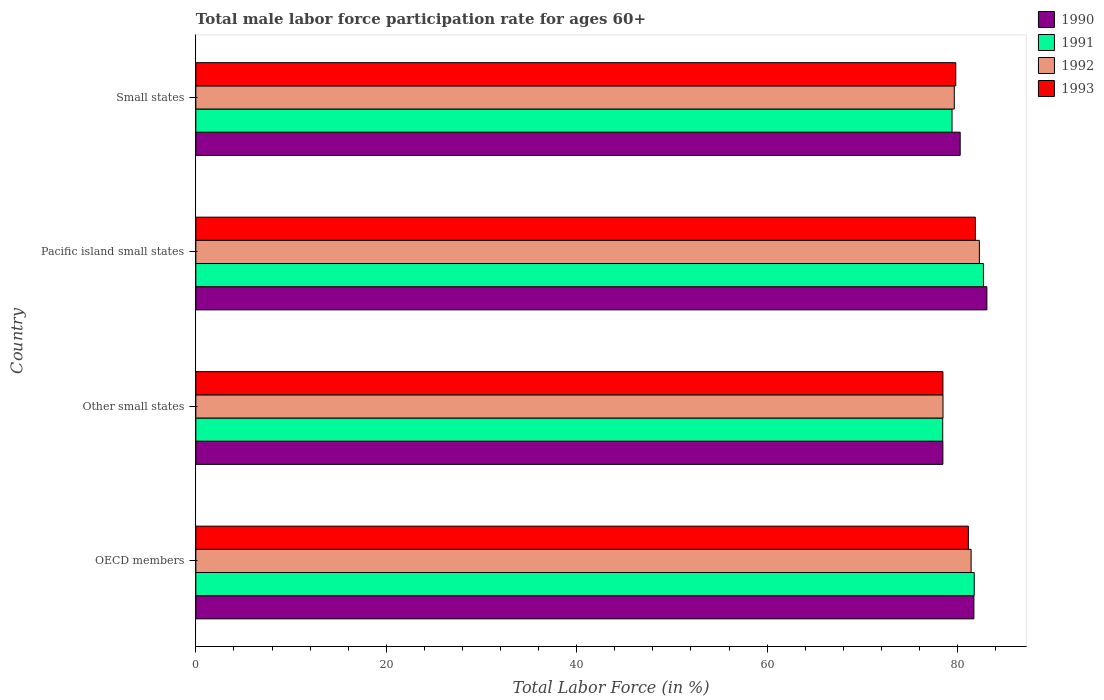How many different coloured bars are there?
Make the answer very short. 4. Are the number of bars per tick equal to the number of legend labels?
Offer a very short reply. Yes. How many bars are there on the 1st tick from the bottom?
Your answer should be very brief. 4. What is the label of the 2nd group of bars from the top?
Your answer should be compact. Pacific island small states. In how many cases, is the number of bars for a given country not equal to the number of legend labels?
Provide a succinct answer. 0. What is the male labor force participation rate in 1991 in Pacific island small states?
Your answer should be very brief. 82.72. Across all countries, what is the maximum male labor force participation rate in 1993?
Your answer should be very brief. 81.87. Across all countries, what is the minimum male labor force participation rate in 1990?
Ensure brevity in your answer.  78.46. In which country was the male labor force participation rate in 1991 maximum?
Your answer should be very brief. Pacific island small states. In which country was the male labor force participation rate in 1992 minimum?
Your answer should be very brief. Other small states. What is the total male labor force participation rate in 1992 in the graph?
Provide a short and direct response. 321.87. What is the difference between the male labor force participation rate in 1990 in OECD members and that in Other small states?
Give a very brief answer. 3.26. What is the difference between the male labor force participation rate in 1990 in OECD members and the male labor force participation rate in 1993 in Small states?
Keep it short and to the point. 1.9. What is the average male labor force participation rate in 1992 per country?
Your answer should be very brief. 80.47. What is the difference between the male labor force participation rate in 1993 and male labor force participation rate in 1990 in Pacific island small states?
Make the answer very short. -1.21. In how many countries, is the male labor force participation rate in 1992 greater than 36 %?
Your response must be concise. 4. What is the ratio of the male labor force participation rate in 1990 in OECD members to that in Pacific island small states?
Your answer should be compact. 0.98. Is the male labor force participation rate in 1990 in OECD members less than that in Pacific island small states?
Provide a short and direct response. Yes. What is the difference between the highest and the second highest male labor force participation rate in 1991?
Provide a succinct answer. 0.97. What is the difference between the highest and the lowest male labor force participation rate in 1990?
Ensure brevity in your answer.  4.62. In how many countries, is the male labor force participation rate in 1992 greater than the average male labor force participation rate in 1992 taken over all countries?
Your response must be concise. 2. Is the sum of the male labor force participation rate in 1993 in OECD members and Other small states greater than the maximum male labor force participation rate in 1992 across all countries?
Offer a terse response. Yes. What does the 3rd bar from the top in Other small states represents?
Offer a very short reply. 1991. How many bars are there?
Offer a terse response. 16. Are all the bars in the graph horizontal?
Your answer should be very brief. Yes. How many countries are there in the graph?
Make the answer very short. 4. What is the difference between two consecutive major ticks on the X-axis?
Your response must be concise. 20. Are the values on the major ticks of X-axis written in scientific E-notation?
Your response must be concise. No. Does the graph contain grids?
Give a very brief answer. No. Where does the legend appear in the graph?
Make the answer very short. Top right. What is the title of the graph?
Provide a short and direct response. Total male labor force participation rate for ages 60+. Does "1991" appear as one of the legend labels in the graph?
Provide a short and direct response. Yes. What is the label or title of the Y-axis?
Provide a succinct answer. Country. What is the Total Labor Force (in %) of 1990 in OECD members?
Offer a terse response. 81.72. What is the Total Labor Force (in %) in 1991 in OECD members?
Provide a succinct answer. 81.76. What is the Total Labor Force (in %) in 1992 in OECD members?
Give a very brief answer. 81.43. What is the Total Labor Force (in %) in 1993 in OECD members?
Your answer should be compact. 81.14. What is the Total Labor Force (in %) of 1990 in Other small states?
Make the answer very short. 78.46. What is the Total Labor Force (in %) of 1991 in Other small states?
Provide a succinct answer. 78.45. What is the Total Labor Force (in %) of 1992 in Other small states?
Make the answer very short. 78.48. What is the Total Labor Force (in %) in 1993 in Other small states?
Keep it short and to the point. 78.47. What is the Total Labor Force (in %) in 1990 in Pacific island small states?
Give a very brief answer. 83.09. What is the Total Labor Force (in %) in 1991 in Pacific island small states?
Offer a very short reply. 82.72. What is the Total Labor Force (in %) of 1992 in Pacific island small states?
Your answer should be compact. 82.3. What is the Total Labor Force (in %) in 1993 in Pacific island small states?
Provide a short and direct response. 81.87. What is the Total Labor Force (in %) in 1990 in Small states?
Keep it short and to the point. 80.28. What is the Total Labor Force (in %) in 1991 in Small states?
Keep it short and to the point. 79.43. What is the Total Labor Force (in %) of 1992 in Small states?
Ensure brevity in your answer.  79.66. What is the Total Labor Force (in %) in 1993 in Small states?
Offer a terse response. 79.82. Across all countries, what is the maximum Total Labor Force (in %) of 1990?
Your response must be concise. 83.09. Across all countries, what is the maximum Total Labor Force (in %) in 1991?
Offer a terse response. 82.72. Across all countries, what is the maximum Total Labor Force (in %) of 1992?
Provide a succinct answer. 82.3. Across all countries, what is the maximum Total Labor Force (in %) in 1993?
Give a very brief answer. 81.87. Across all countries, what is the minimum Total Labor Force (in %) in 1990?
Provide a succinct answer. 78.46. Across all countries, what is the minimum Total Labor Force (in %) in 1991?
Ensure brevity in your answer.  78.45. Across all countries, what is the minimum Total Labor Force (in %) of 1992?
Provide a short and direct response. 78.48. Across all countries, what is the minimum Total Labor Force (in %) in 1993?
Your answer should be compact. 78.47. What is the total Total Labor Force (in %) of 1990 in the graph?
Keep it short and to the point. 323.55. What is the total Total Labor Force (in %) of 1991 in the graph?
Your response must be concise. 322.36. What is the total Total Labor Force (in %) in 1992 in the graph?
Keep it short and to the point. 321.87. What is the total Total Labor Force (in %) of 1993 in the graph?
Offer a very short reply. 321.3. What is the difference between the Total Labor Force (in %) of 1990 in OECD members and that in Other small states?
Provide a short and direct response. 3.26. What is the difference between the Total Labor Force (in %) of 1991 in OECD members and that in Other small states?
Your answer should be very brief. 3.31. What is the difference between the Total Labor Force (in %) in 1992 in OECD members and that in Other small states?
Keep it short and to the point. 2.95. What is the difference between the Total Labor Force (in %) in 1993 in OECD members and that in Other small states?
Provide a succinct answer. 2.67. What is the difference between the Total Labor Force (in %) in 1990 in OECD members and that in Pacific island small states?
Your response must be concise. -1.36. What is the difference between the Total Labor Force (in %) in 1991 in OECD members and that in Pacific island small states?
Keep it short and to the point. -0.97. What is the difference between the Total Labor Force (in %) in 1992 in OECD members and that in Pacific island small states?
Your answer should be very brief. -0.87. What is the difference between the Total Labor Force (in %) in 1993 in OECD members and that in Pacific island small states?
Make the answer very short. -0.73. What is the difference between the Total Labor Force (in %) of 1990 in OECD members and that in Small states?
Your response must be concise. 1.44. What is the difference between the Total Labor Force (in %) of 1991 in OECD members and that in Small states?
Offer a terse response. 2.33. What is the difference between the Total Labor Force (in %) of 1992 in OECD members and that in Small states?
Your response must be concise. 1.77. What is the difference between the Total Labor Force (in %) in 1993 in OECD members and that in Small states?
Provide a succinct answer. 1.32. What is the difference between the Total Labor Force (in %) of 1990 in Other small states and that in Pacific island small states?
Ensure brevity in your answer.  -4.62. What is the difference between the Total Labor Force (in %) in 1991 in Other small states and that in Pacific island small states?
Make the answer very short. -4.28. What is the difference between the Total Labor Force (in %) of 1992 in Other small states and that in Pacific island small states?
Give a very brief answer. -3.82. What is the difference between the Total Labor Force (in %) of 1993 in Other small states and that in Pacific island small states?
Keep it short and to the point. -3.4. What is the difference between the Total Labor Force (in %) in 1990 in Other small states and that in Small states?
Give a very brief answer. -1.82. What is the difference between the Total Labor Force (in %) in 1991 in Other small states and that in Small states?
Provide a short and direct response. -0.98. What is the difference between the Total Labor Force (in %) of 1992 in Other small states and that in Small states?
Keep it short and to the point. -1.19. What is the difference between the Total Labor Force (in %) of 1993 in Other small states and that in Small states?
Keep it short and to the point. -1.35. What is the difference between the Total Labor Force (in %) of 1990 in Pacific island small states and that in Small states?
Provide a short and direct response. 2.8. What is the difference between the Total Labor Force (in %) in 1991 in Pacific island small states and that in Small states?
Ensure brevity in your answer.  3.3. What is the difference between the Total Labor Force (in %) in 1992 in Pacific island small states and that in Small states?
Your response must be concise. 2.63. What is the difference between the Total Labor Force (in %) of 1993 in Pacific island small states and that in Small states?
Keep it short and to the point. 2.05. What is the difference between the Total Labor Force (in %) of 1990 in OECD members and the Total Labor Force (in %) of 1991 in Other small states?
Offer a terse response. 3.27. What is the difference between the Total Labor Force (in %) in 1990 in OECD members and the Total Labor Force (in %) in 1992 in Other small states?
Make the answer very short. 3.24. What is the difference between the Total Labor Force (in %) of 1990 in OECD members and the Total Labor Force (in %) of 1993 in Other small states?
Give a very brief answer. 3.25. What is the difference between the Total Labor Force (in %) in 1991 in OECD members and the Total Labor Force (in %) in 1992 in Other small states?
Ensure brevity in your answer.  3.28. What is the difference between the Total Labor Force (in %) of 1991 in OECD members and the Total Labor Force (in %) of 1993 in Other small states?
Ensure brevity in your answer.  3.29. What is the difference between the Total Labor Force (in %) of 1992 in OECD members and the Total Labor Force (in %) of 1993 in Other small states?
Give a very brief answer. 2.96. What is the difference between the Total Labor Force (in %) in 1990 in OECD members and the Total Labor Force (in %) in 1991 in Pacific island small states?
Provide a succinct answer. -1. What is the difference between the Total Labor Force (in %) of 1990 in OECD members and the Total Labor Force (in %) of 1992 in Pacific island small states?
Ensure brevity in your answer.  -0.58. What is the difference between the Total Labor Force (in %) in 1990 in OECD members and the Total Labor Force (in %) in 1993 in Pacific island small states?
Your response must be concise. -0.15. What is the difference between the Total Labor Force (in %) in 1991 in OECD members and the Total Labor Force (in %) in 1992 in Pacific island small states?
Your answer should be very brief. -0.54. What is the difference between the Total Labor Force (in %) in 1991 in OECD members and the Total Labor Force (in %) in 1993 in Pacific island small states?
Your response must be concise. -0.12. What is the difference between the Total Labor Force (in %) of 1992 in OECD members and the Total Labor Force (in %) of 1993 in Pacific island small states?
Provide a succinct answer. -0.44. What is the difference between the Total Labor Force (in %) of 1990 in OECD members and the Total Labor Force (in %) of 1991 in Small states?
Provide a succinct answer. 2.29. What is the difference between the Total Labor Force (in %) in 1990 in OECD members and the Total Labor Force (in %) in 1992 in Small states?
Make the answer very short. 2.06. What is the difference between the Total Labor Force (in %) of 1990 in OECD members and the Total Labor Force (in %) of 1993 in Small states?
Make the answer very short. 1.9. What is the difference between the Total Labor Force (in %) in 1991 in OECD members and the Total Labor Force (in %) in 1992 in Small states?
Make the answer very short. 2.09. What is the difference between the Total Labor Force (in %) of 1991 in OECD members and the Total Labor Force (in %) of 1993 in Small states?
Provide a succinct answer. 1.94. What is the difference between the Total Labor Force (in %) of 1992 in OECD members and the Total Labor Force (in %) of 1993 in Small states?
Give a very brief answer. 1.61. What is the difference between the Total Labor Force (in %) in 1990 in Other small states and the Total Labor Force (in %) in 1991 in Pacific island small states?
Keep it short and to the point. -4.26. What is the difference between the Total Labor Force (in %) in 1990 in Other small states and the Total Labor Force (in %) in 1992 in Pacific island small states?
Provide a short and direct response. -3.83. What is the difference between the Total Labor Force (in %) in 1990 in Other small states and the Total Labor Force (in %) in 1993 in Pacific island small states?
Give a very brief answer. -3.41. What is the difference between the Total Labor Force (in %) in 1991 in Other small states and the Total Labor Force (in %) in 1992 in Pacific island small states?
Your response must be concise. -3.85. What is the difference between the Total Labor Force (in %) in 1991 in Other small states and the Total Labor Force (in %) in 1993 in Pacific island small states?
Provide a succinct answer. -3.43. What is the difference between the Total Labor Force (in %) in 1992 in Other small states and the Total Labor Force (in %) in 1993 in Pacific island small states?
Your answer should be very brief. -3.4. What is the difference between the Total Labor Force (in %) of 1990 in Other small states and the Total Labor Force (in %) of 1991 in Small states?
Your answer should be compact. -0.96. What is the difference between the Total Labor Force (in %) of 1990 in Other small states and the Total Labor Force (in %) of 1992 in Small states?
Your response must be concise. -1.2. What is the difference between the Total Labor Force (in %) of 1990 in Other small states and the Total Labor Force (in %) of 1993 in Small states?
Make the answer very short. -1.36. What is the difference between the Total Labor Force (in %) in 1991 in Other small states and the Total Labor Force (in %) in 1992 in Small states?
Make the answer very short. -1.22. What is the difference between the Total Labor Force (in %) of 1991 in Other small states and the Total Labor Force (in %) of 1993 in Small states?
Your response must be concise. -1.37. What is the difference between the Total Labor Force (in %) of 1992 in Other small states and the Total Labor Force (in %) of 1993 in Small states?
Ensure brevity in your answer.  -1.34. What is the difference between the Total Labor Force (in %) in 1990 in Pacific island small states and the Total Labor Force (in %) in 1991 in Small states?
Your response must be concise. 3.66. What is the difference between the Total Labor Force (in %) in 1990 in Pacific island small states and the Total Labor Force (in %) in 1992 in Small states?
Give a very brief answer. 3.42. What is the difference between the Total Labor Force (in %) of 1990 in Pacific island small states and the Total Labor Force (in %) of 1993 in Small states?
Make the answer very short. 3.27. What is the difference between the Total Labor Force (in %) in 1991 in Pacific island small states and the Total Labor Force (in %) in 1992 in Small states?
Your response must be concise. 3.06. What is the difference between the Total Labor Force (in %) in 1991 in Pacific island small states and the Total Labor Force (in %) in 1993 in Small states?
Keep it short and to the point. 2.91. What is the difference between the Total Labor Force (in %) of 1992 in Pacific island small states and the Total Labor Force (in %) of 1993 in Small states?
Keep it short and to the point. 2.48. What is the average Total Labor Force (in %) of 1990 per country?
Keep it short and to the point. 80.89. What is the average Total Labor Force (in %) in 1991 per country?
Your answer should be compact. 80.59. What is the average Total Labor Force (in %) in 1992 per country?
Your answer should be compact. 80.47. What is the average Total Labor Force (in %) of 1993 per country?
Ensure brevity in your answer.  80.33. What is the difference between the Total Labor Force (in %) of 1990 and Total Labor Force (in %) of 1991 in OECD members?
Make the answer very short. -0.04. What is the difference between the Total Labor Force (in %) of 1990 and Total Labor Force (in %) of 1992 in OECD members?
Offer a terse response. 0.29. What is the difference between the Total Labor Force (in %) of 1990 and Total Labor Force (in %) of 1993 in OECD members?
Offer a terse response. 0.58. What is the difference between the Total Labor Force (in %) of 1991 and Total Labor Force (in %) of 1992 in OECD members?
Keep it short and to the point. 0.33. What is the difference between the Total Labor Force (in %) of 1991 and Total Labor Force (in %) of 1993 in OECD members?
Provide a short and direct response. 0.62. What is the difference between the Total Labor Force (in %) in 1992 and Total Labor Force (in %) in 1993 in OECD members?
Ensure brevity in your answer.  0.29. What is the difference between the Total Labor Force (in %) in 1990 and Total Labor Force (in %) in 1991 in Other small states?
Provide a short and direct response. 0.02. What is the difference between the Total Labor Force (in %) in 1990 and Total Labor Force (in %) in 1992 in Other small states?
Your answer should be very brief. -0.01. What is the difference between the Total Labor Force (in %) in 1990 and Total Labor Force (in %) in 1993 in Other small states?
Your response must be concise. -0.01. What is the difference between the Total Labor Force (in %) in 1991 and Total Labor Force (in %) in 1992 in Other small states?
Provide a short and direct response. -0.03. What is the difference between the Total Labor Force (in %) of 1991 and Total Labor Force (in %) of 1993 in Other small states?
Your answer should be very brief. -0.02. What is the difference between the Total Labor Force (in %) of 1992 and Total Labor Force (in %) of 1993 in Other small states?
Your answer should be compact. 0.01. What is the difference between the Total Labor Force (in %) of 1990 and Total Labor Force (in %) of 1991 in Pacific island small states?
Give a very brief answer. 0.36. What is the difference between the Total Labor Force (in %) in 1990 and Total Labor Force (in %) in 1992 in Pacific island small states?
Your answer should be compact. 0.79. What is the difference between the Total Labor Force (in %) in 1990 and Total Labor Force (in %) in 1993 in Pacific island small states?
Offer a very short reply. 1.21. What is the difference between the Total Labor Force (in %) of 1991 and Total Labor Force (in %) of 1992 in Pacific island small states?
Your answer should be very brief. 0.43. What is the difference between the Total Labor Force (in %) in 1991 and Total Labor Force (in %) in 1993 in Pacific island small states?
Your response must be concise. 0.85. What is the difference between the Total Labor Force (in %) of 1992 and Total Labor Force (in %) of 1993 in Pacific island small states?
Ensure brevity in your answer.  0.42. What is the difference between the Total Labor Force (in %) of 1990 and Total Labor Force (in %) of 1991 in Small states?
Your response must be concise. 0.86. What is the difference between the Total Labor Force (in %) in 1990 and Total Labor Force (in %) in 1992 in Small states?
Ensure brevity in your answer.  0.62. What is the difference between the Total Labor Force (in %) in 1990 and Total Labor Force (in %) in 1993 in Small states?
Your answer should be very brief. 0.46. What is the difference between the Total Labor Force (in %) in 1991 and Total Labor Force (in %) in 1992 in Small states?
Keep it short and to the point. -0.24. What is the difference between the Total Labor Force (in %) in 1991 and Total Labor Force (in %) in 1993 in Small states?
Your response must be concise. -0.39. What is the difference between the Total Labor Force (in %) in 1992 and Total Labor Force (in %) in 1993 in Small states?
Your answer should be compact. -0.15. What is the ratio of the Total Labor Force (in %) in 1990 in OECD members to that in Other small states?
Keep it short and to the point. 1.04. What is the ratio of the Total Labor Force (in %) of 1991 in OECD members to that in Other small states?
Your response must be concise. 1.04. What is the ratio of the Total Labor Force (in %) of 1992 in OECD members to that in Other small states?
Make the answer very short. 1.04. What is the ratio of the Total Labor Force (in %) of 1993 in OECD members to that in Other small states?
Provide a short and direct response. 1.03. What is the ratio of the Total Labor Force (in %) of 1990 in OECD members to that in Pacific island small states?
Your answer should be very brief. 0.98. What is the ratio of the Total Labor Force (in %) of 1991 in OECD members to that in Pacific island small states?
Offer a terse response. 0.99. What is the ratio of the Total Labor Force (in %) in 1990 in OECD members to that in Small states?
Ensure brevity in your answer.  1.02. What is the ratio of the Total Labor Force (in %) of 1991 in OECD members to that in Small states?
Give a very brief answer. 1.03. What is the ratio of the Total Labor Force (in %) in 1992 in OECD members to that in Small states?
Your answer should be very brief. 1.02. What is the ratio of the Total Labor Force (in %) in 1993 in OECD members to that in Small states?
Give a very brief answer. 1.02. What is the ratio of the Total Labor Force (in %) in 1991 in Other small states to that in Pacific island small states?
Keep it short and to the point. 0.95. What is the ratio of the Total Labor Force (in %) of 1992 in Other small states to that in Pacific island small states?
Your response must be concise. 0.95. What is the ratio of the Total Labor Force (in %) in 1993 in Other small states to that in Pacific island small states?
Ensure brevity in your answer.  0.96. What is the ratio of the Total Labor Force (in %) in 1990 in Other small states to that in Small states?
Make the answer very short. 0.98. What is the ratio of the Total Labor Force (in %) of 1992 in Other small states to that in Small states?
Provide a succinct answer. 0.99. What is the ratio of the Total Labor Force (in %) in 1993 in Other small states to that in Small states?
Provide a succinct answer. 0.98. What is the ratio of the Total Labor Force (in %) of 1990 in Pacific island small states to that in Small states?
Your answer should be compact. 1.03. What is the ratio of the Total Labor Force (in %) of 1991 in Pacific island small states to that in Small states?
Provide a short and direct response. 1.04. What is the ratio of the Total Labor Force (in %) of 1992 in Pacific island small states to that in Small states?
Make the answer very short. 1.03. What is the ratio of the Total Labor Force (in %) of 1993 in Pacific island small states to that in Small states?
Offer a very short reply. 1.03. What is the difference between the highest and the second highest Total Labor Force (in %) in 1990?
Give a very brief answer. 1.36. What is the difference between the highest and the second highest Total Labor Force (in %) of 1991?
Provide a short and direct response. 0.97. What is the difference between the highest and the second highest Total Labor Force (in %) of 1992?
Offer a terse response. 0.87. What is the difference between the highest and the second highest Total Labor Force (in %) in 1993?
Provide a short and direct response. 0.73. What is the difference between the highest and the lowest Total Labor Force (in %) in 1990?
Give a very brief answer. 4.62. What is the difference between the highest and the lowest Total Labor Force (in %) in 1991?
Offer a terse response. 4.28. What is the difference between the highest and the lowest Total Labor Force (in %) in 1992?
Offer a terse response. 3.82. What is the difference between the highest and the lowest Total Labor Force (in %) in 1993?
Keep it short and to the point. 3.4. 